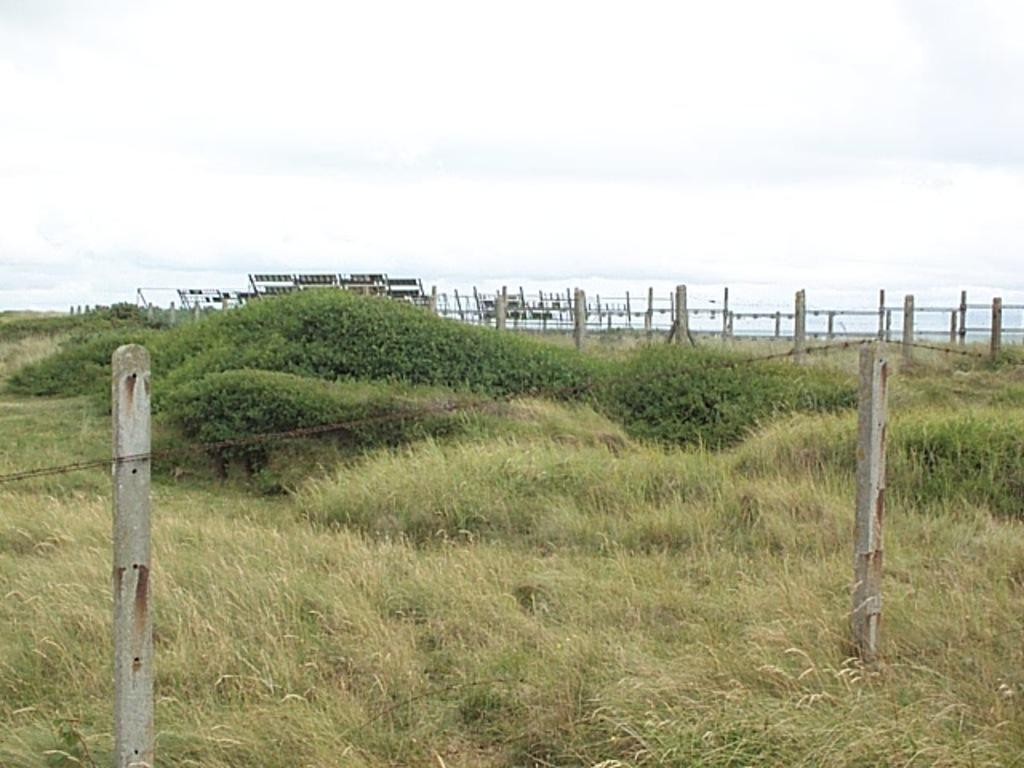What type of vegetation is in the middle of the image? There is grass in the middle of the image. How is the grass being protected or contained in the image? The grass is covered by fencing. What is visible at the top of the image? The sky is visible at the top of the image. What other type of vegetation is present in the image? There are plants beside the grass in the image. What type of mist can be seen surrounding the beam in the image? There is no mist or beam present in the image. 